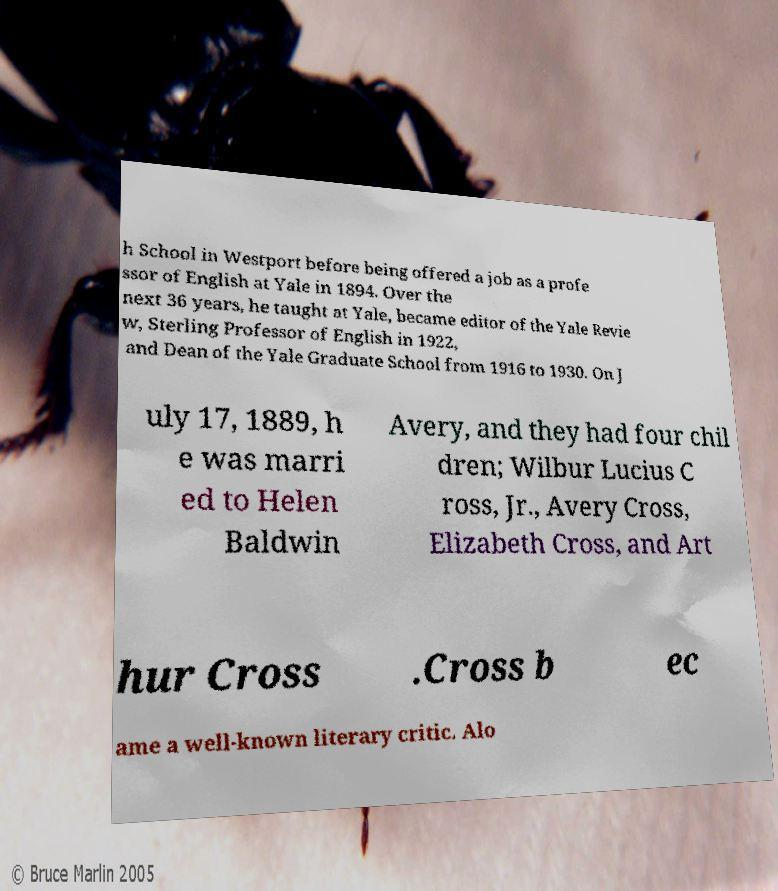What messages or text are displayed in this image? I need them in a readable, typed format. h School in Westport before being offered a job as a profe ssor of English at Yale in 1894. Over the next 36 years, he taught at Yale, became editor of the Yale Revie w, Sterling Professor of English in 1922, and Dean of the Yale Graduate School from 1916 to 1930. On J uly 17, 1889, h e was marri ed to Helen Baldwin Avery, and they had four chil dren; Wilbur Lucius C ross, Jr., Avery Cross, Elizabeth Cross, and Art hur Cross .Cross b ec ame a well-known literary critic. Alo 